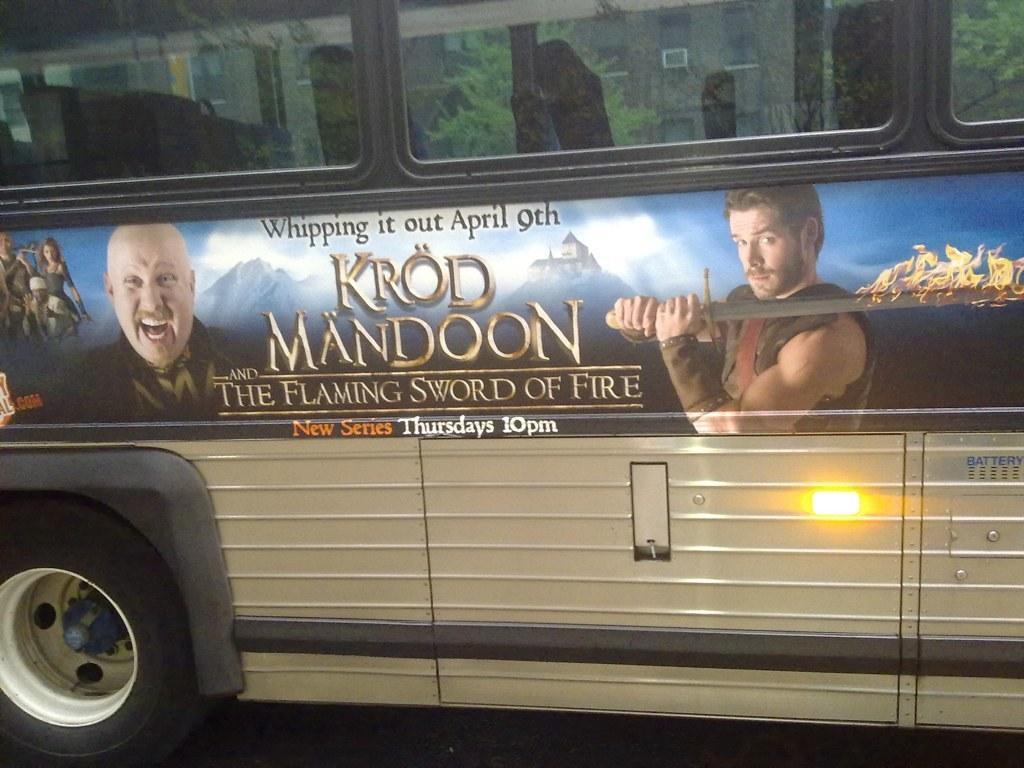In one or two sentences, can you explain what this image depicts? In this image there is a bus, there is some text and images of a few people are on the bus, through the window of the bus we can see there are trees. 